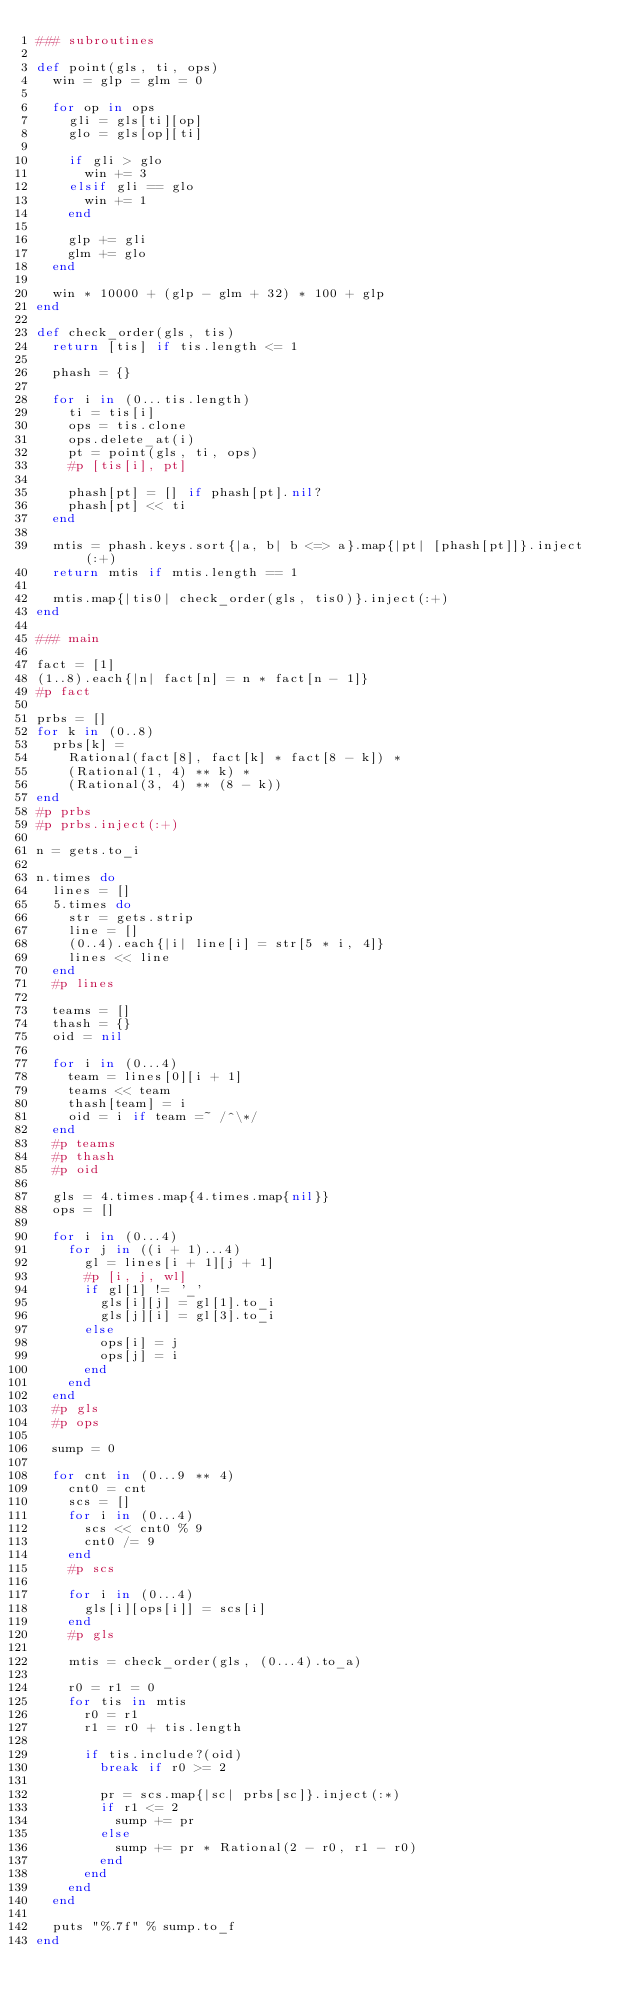<code> <loc_0><loc_0><loc_500><loc_500><_Ruby_>### subroutines

def point(gls, ti, ops)
  win = glp = glm = 0

  for op in ops
    gli = gls[ti][op]
    glo = gls[op][ti]

    if gli > glo
      win += 3
    elsif gli == glo
      win += 1
    end

    glp += gli
    glm += glo
  end

  win * 10000 + (glp - glm + 32) * 100 + glp
end

def check_order(gls, tis)
  return [tis] if tis.length <= 1

  phash = {}

  for i in (0...tis.length)
    ti = tis[i]
    ops = tis.clone
    ops.delete_at(i)
    pt = point(gls, ti, ops)
    #p [tis[i], pt]

    phash[pt] = [] if phash[pt].nil?
    phash[pt] << ti
  end

  mtis = phash.keys.sort{|a, b| b <=> a}.map{|pt| [phash[pt]]}.inject(:+)
  return mtis if mtis.length == 1

  mtis.map{|tis0| check_order(gls, tis0)}.inject(:+)
end

### main

fact = [1]
(1..8).each{|n| fact[n] = n * fact[n - 1]}
#p fact

prbs = []
for k in (0..8)
  prbs[k] =
    Rational(fact[8], fact[k] * fact[8 - k]) *
    (Rational(1, 4) ** k) *
    (Rational(3, 4) ** (8 - k))
end
#p prbs
#p prbs.inject(:+)

n = gets.to_i

n.times do
  lines = []
  5.times do
    str = gets.strip
    line = []
    (0..4).each{|i| line[i] = str[5 * i, 4]}
    lines << line
  end
  #p lines

  teams = []
  thash = {}
  oid = nil

  for i in (0...4)
    team = lines[0][i + 1]
    teams << team
    thash[team] = i
    oid = i if team =~ /^\*/
  end
  #p teams
  #p thash
  #p oid

  gls = 4.times.map{4.times.map{nil}}
  ops = []

  for i in (0...4)
    for j in ((i + 1)...4)
      gl = lines[i + 1][j + 1]
      #p [i, j, wl]
      if gl[1] != '_'
        gls[i][j] = gl[1].to_i
        gls[j][i] = gl[3].to_i
      else
        ops[i] = j
        ops[j] = i
      end
    end
  end
  #p gls
  #p ops

  sump = 0

  for cnt in (0...9 ** 4)
    cnt0 = cnt
    scs = []
    for i in (0...4)
      scs << cnt0 % 9
      cnt0 /= 9
    end
    #p scs

    for i in (0...4)
      gls[i][ops[i]] = scs[i]
    end
    #p gls

    mtis = check_order(gls, (0...4).to_a)

    r0 = r1 = 0
    for tis in mtis
      r0 = r1
      r1 = r0 + tis.length

      if tis.include?(oid)
        break if r0 >= 2

        pr = scs.map{|sc| prbs[sc]}.inject(:*)
        if r1 <= 2
          sump += pr
        else
          sump += pr * Rational(2 - r0, r1 - r0)
        end
      end
    end
  end

  puts "%.7f" % sump.to_f
end</code> 